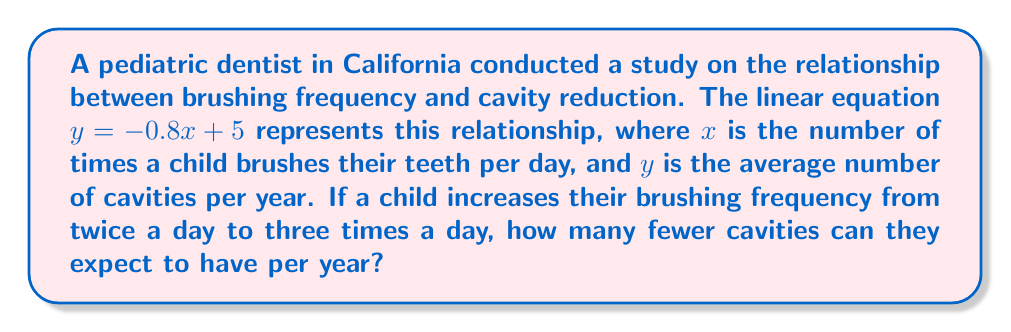Help me with this question. Let's approach this step-by-step:

1) We have the linear equation: $y = -0.8x + 5$
   Where $x$ is the brushing frequency per day, and $y$ is the number of cavities per year.

2) To find the difference in cavities, we need to calculate:
   (Cavities when brushing 2 times) - (Cavities when brushing 3 times)

3) For $x = 2$ (brushing twice a day):
   $y_1 = -0.8(2) + 5 = -1.6 + 5 = 3.4$ cavities per year

4) For $x = 3$ (brushing three times a day):
   $y_2 = -0.8(3) + 5 = -2.4 + 5 = 2.6$ cavities per year

5) The difference in cavities:
   $y_1 - y_2 = 3.4 - 2.6 = 0.8$

Therefore, by increasing brushing frequency from twice to three times a day, a child can expect to have 0.8 fewer cavities per year.
Answer: 0.8 fewer cavities per year 